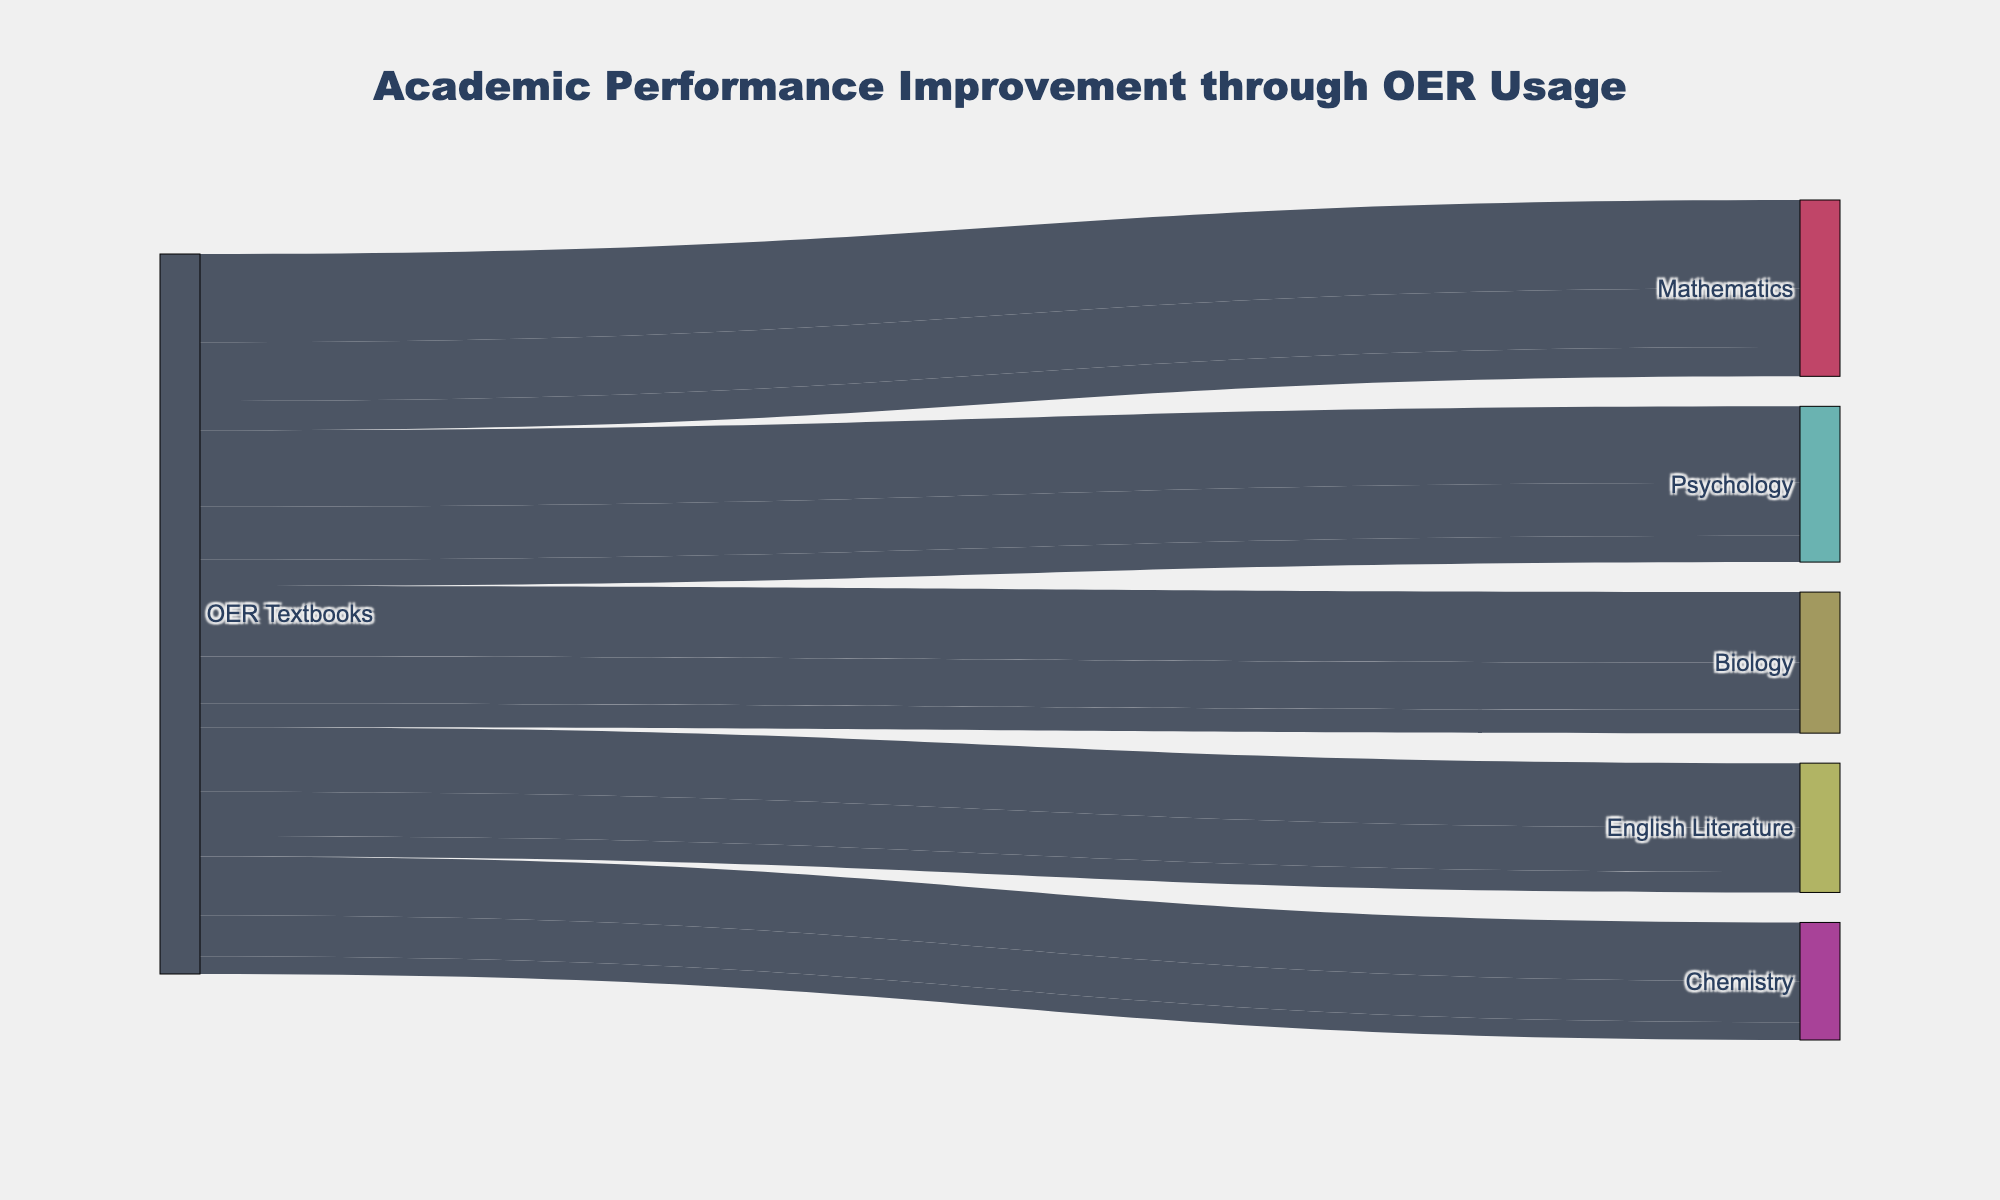What is the title of the Sankey diagram? The title is shown at the top of the diagram in a larger and bold font, it is meant to tell viewers the overall topic of the figure.
Answer: Academic Performance Improvement through OER Usage Which subject shows the largest number of students with a 1.0-1.5 GPA improvement? Look at the node representing the students in each subject with a 1.0-1.5 GPA improvement and identify the one with the highest value.
Answer: Mathematics How many students experienced a 1.5-2.0 GPA improvement in Biology? Check the link that connects the Biology node to the 1.5-2.0 GPA improvement node and find the value of that link.
Answer: 40 What is the total number of students who saw a GPA improvement between 0.5 and 1.0, regardless of the subject? Sum the values from the links that connect each subject to the 0.5-1.0 GPA improvement node.
Answer: 610 Which subject has the fewest students with grade improvements? Compare the total values of students from each subject node to identify the one with the smallest total.
Answer: Chemistry How does the number of students improving by 1.0-1.5 GPA in Psychology compare to those in English Literature? Check the link values for students with a 1.0-1.5 GPA improvement in both Psychology and English Literature and compare them directly.
Answer: Psychology has more students How many students experienced a GPA improvement of 1.5-2.0 across all subjects? Sum the number of students who experienced this GPA improvement from each subject by looking at the relevant links.
Answer: 200 Compare the total number of students in Mathematics to the total number of students in Chemistry. Add up the students in each GPA improvement category for Mathematics and Chemistry to find their respective totals, then compare.
Answer: Mathematics has more students What is the most common GPA improvement range for students using OER Textbooks? Identify the GPA improvement range that has the highest total number of students across all subjects.
Answer: 0.5-1.0 GPA Which subject had more students seeing a GPA improvement of 1.5-2.0: English Literature or Chemistry? Compare the respective link values for the 1.5-2.0 GPA improvement range in English Literature and Chemistry.
Answer: English Literature 